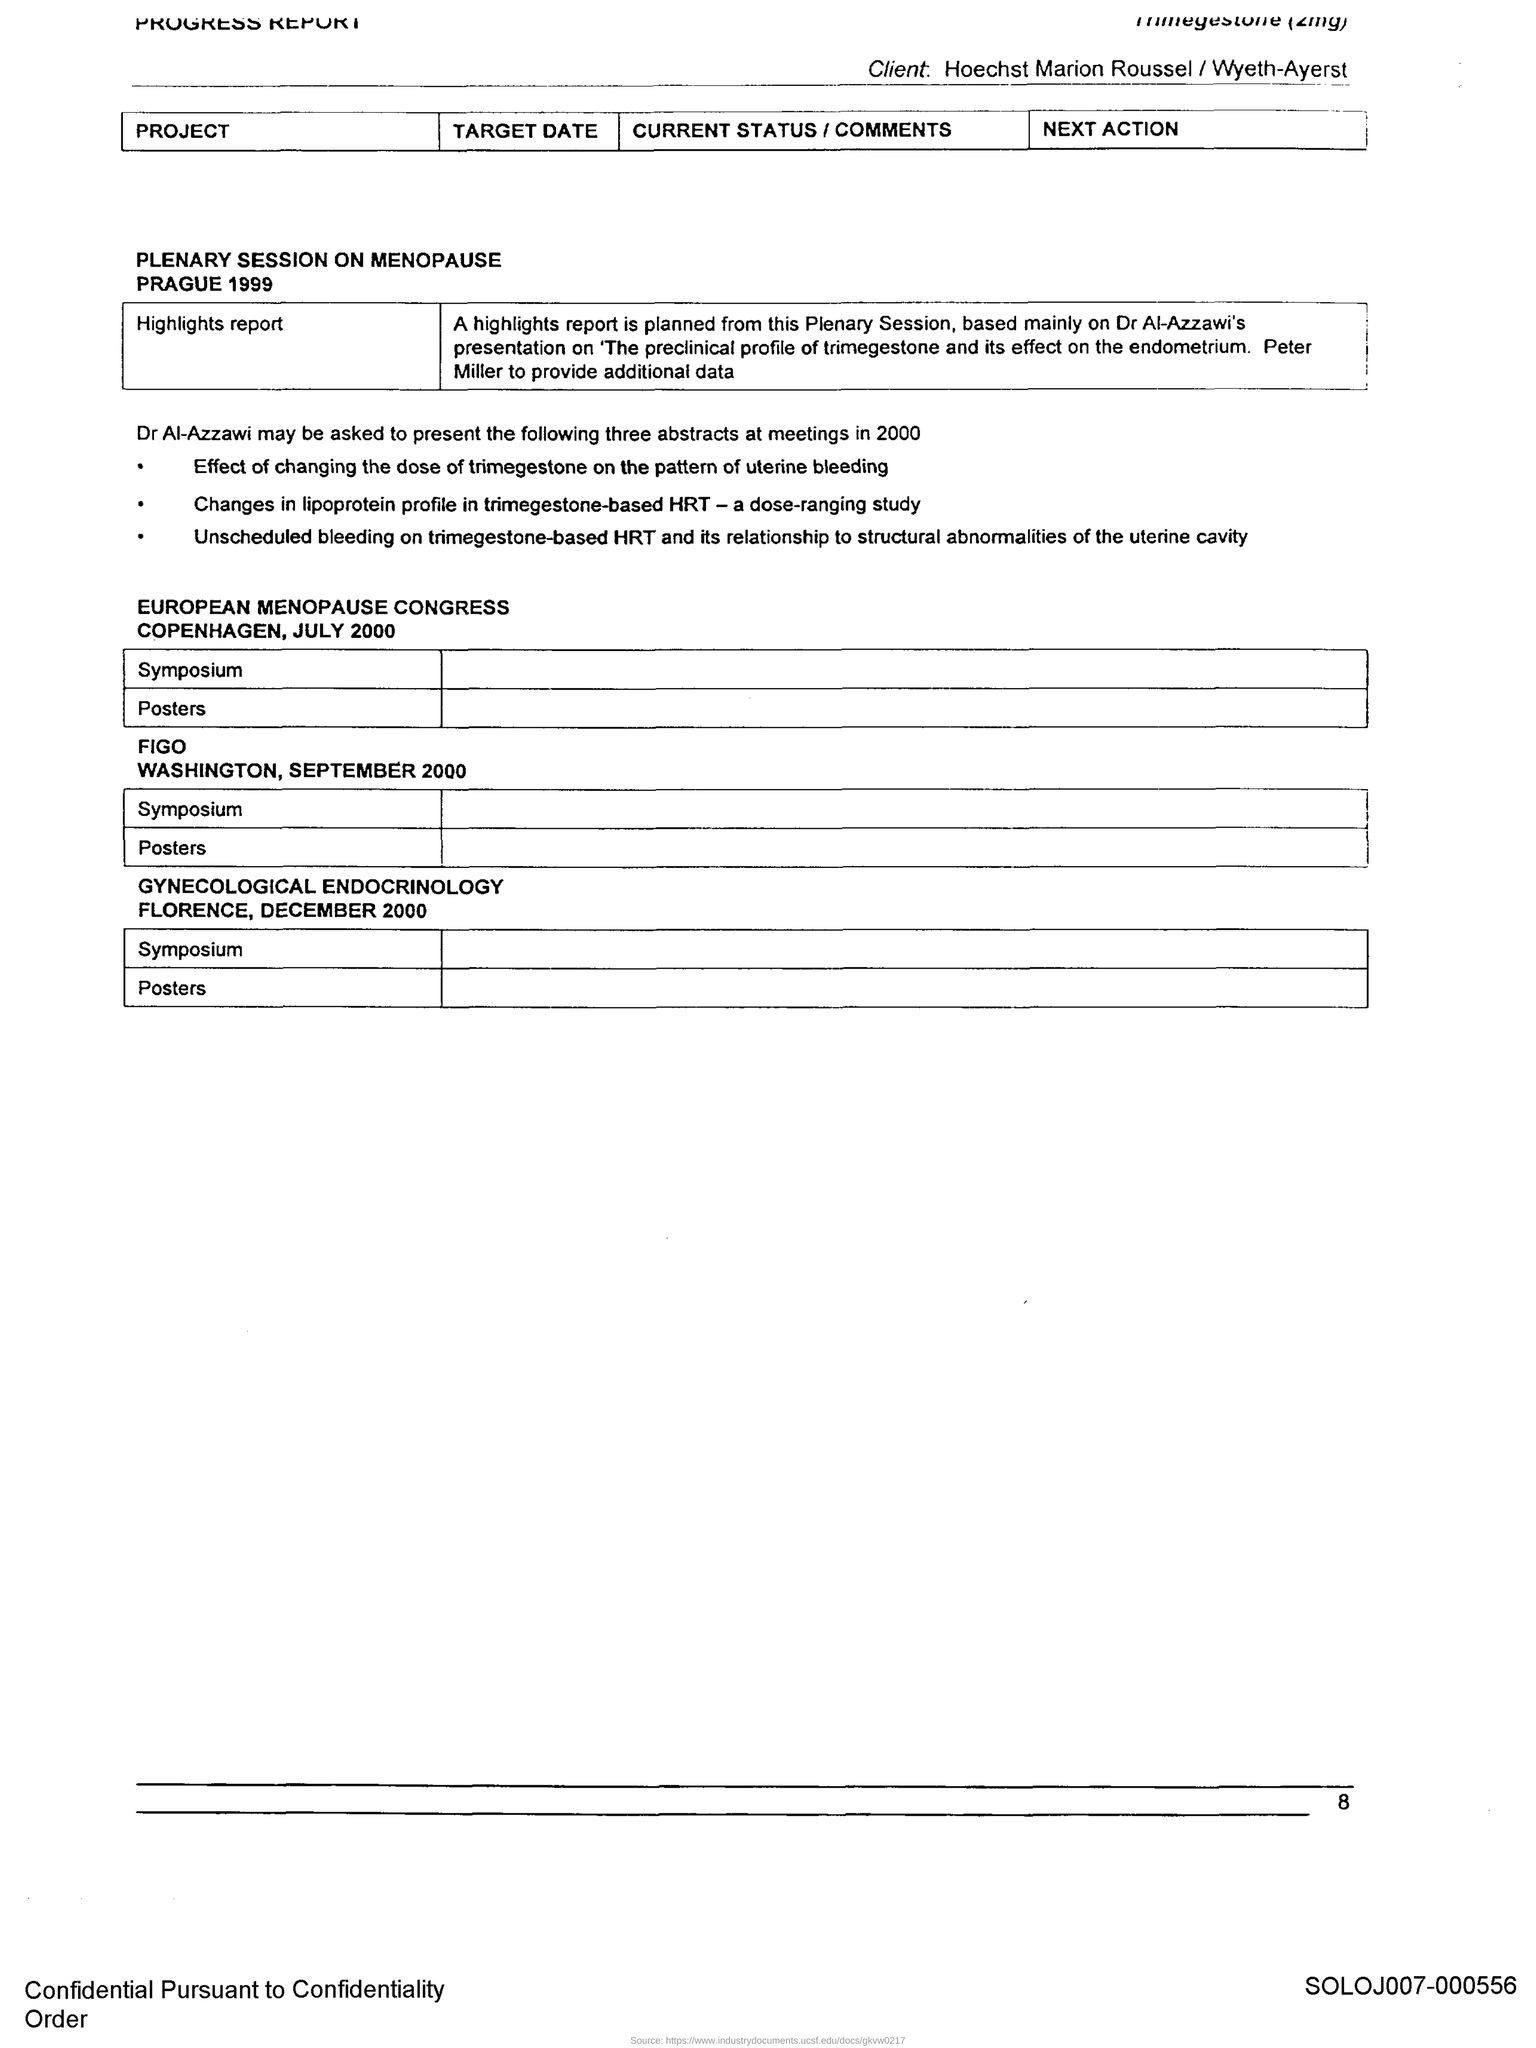Indicate a few pertinent items in this graphic. The page number is 8. A plenary session on the menopause was held in 1999. A Gynecological Endocrinology session was held in Florence. The European Menopause Congress took place in Copenhagen. 